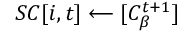<formula> <loc_0><loc_0><loc_500><loc_500>S C [ i , t ] \longleftarrow { [ C _ { \beta } ^ { t + 1 } ] }</formula> 